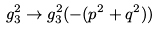Convert formula to latex. <formula><loc_0><loc_0><loc_500><loc_500>g _ { 3 } ^ { 2 } \to g _ { 3 } ^ { 2 } ( - ( p ^ { 2 } + q ^ { 2 } ) )</formula> 